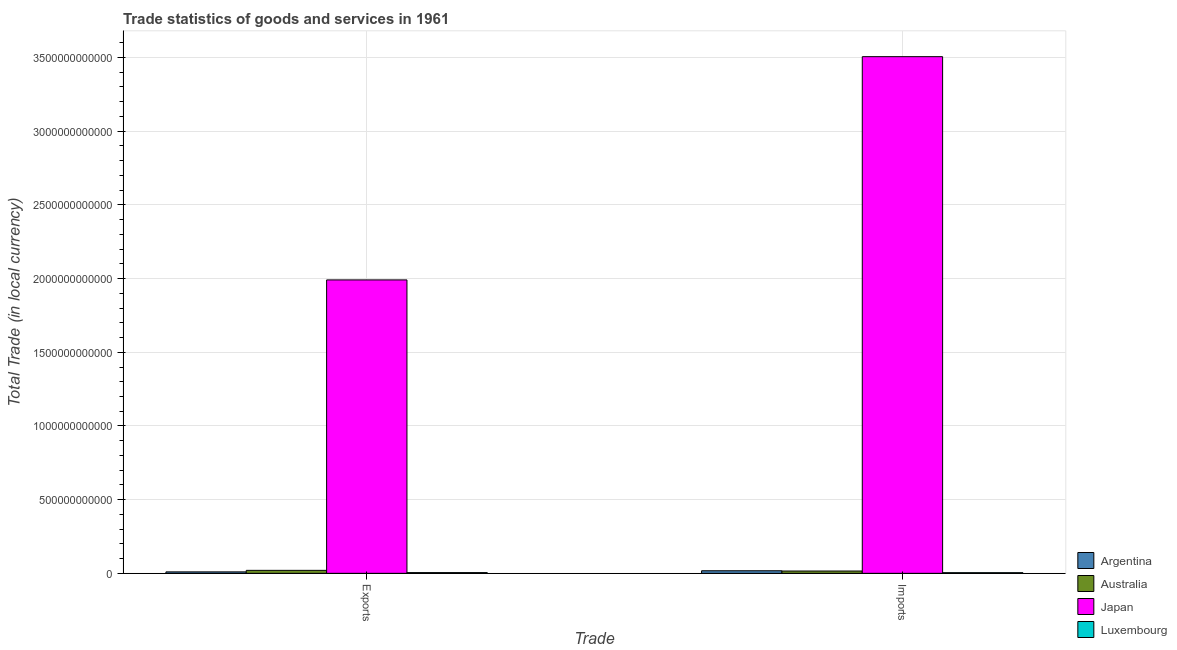How many groups of bars are there?
Ensure brevity in your answer.  2. Are the number of bars per tick equal to the number of legend labels?
Offer a terse response. Yes. How many bars are there on the 2nd tick from the left?
Provide a short and direct response. 4. What is the label of the 2nd group of bars from the left?
Provide a succinct answer. Imports. What is the export of goods and services in Luxembourg?
Give a very brief answer. 4.98e+09. Across all countries, what is the maximum export of goods and services?
Offer a very short reply. 1.99e+12. Across all countries, what is the minimum imports of goods and services?
Make the answer very short. 4.41e+09. In which country was the imports of goods and services minimum?
Make the answer very short. Luxembourg. What is the total export of goods and services in the graph?
Make the answer very short. 2.03e+12. What is the difference between the imports of goods and services in Japan and that in Australia?
Provide a short and direct response. 3.49e+12. What is the difference between the export of goods and services in Japan and the imports of goods and services in Argentina?
Your answer should be very brief. 1.97e+12. What is the average export of goods and services per country?
Ensure brevity in your answer.  5.07e+11. What is the difference between the export of goods and services and imports of goods and services in Australia?
Your answer should be very brief. 4.57e+09. In how many countries, is the export of goods and services greater than 200000000000 LCU?
Your response must be concise. 1. What is the ratio of the export of goods and services in Australia to that in Japan?
Offer a very short reply. 0.01. In how many countries, is the imports of goods and services greater than the average imports of goods and services taken over all countries?
Give a very brief answer. 1. What does the 1st bar from the left in Exports represents?
Offer a terse response. Argentina. What does the 3rd bar from the right in Exports represents?
Ensure brevity in your answer.  Australia. Are all the bars in the graph horizontal?
Offer a terse response. No. How many countries are there in the graph?
Ensure brevity in your answer.  4. What is the difference between two consecutive major ticks on the Y-axis?
Provide a succinct answer. 5.00e+11. Where does the legend appear in the graph?
Give a very brief answer. Bottom right. How are the legend labels stacked?
Offer a terse response. Vertical. What is the title of the graph?
Your answer should be very brief. Trade statistics of goods and services in 1961. What is the label or title of the X-axis?
Your answer should be compact. Trade. What is the label or title of the Y-axis?
Offer a very short reply. Total Trade (in local currency). What is the Total Trade (in local currency) in Argentina in Exports?
Offer a terse response. 9.88e+09. What is the Total Trade (in local currency) in Australia in Exports?
Your answer should be compact. 2.03e+1. What is the Total Trade (in local currency) of Japan in Exports?
Your response must be concise. 1.99e+12. What is the Total Trade (in local currency) of Luxembourg in Exports?
Keep it short and to the point. 4.98e+09. What is the Total Trade (in local currency) in Argentina in Imports?
Provide a succinct answer. 1.74e+1. What is the Total Trade (in local currency) of Australia in Imports?
Keep it short and to the point. 1.57e+1. What is the Total Trade (in local currency) of Japan in Imports?
Offer a terse response. 3.51e+12. What is the Total Trade (in local currency) in Luxembourg in Imports?
Your response must be concise. 4.41e+09. Across all Trade, what is the maximum Total Trade (in local currency) of Argentina?
Give a very brief answer. 1.74e+1. Across all Trade, what is the maximum Total Trade (in local currency) of Australia?
Give a very brief answer. 2.03e+1. Across all Trade, what is the maximum Total Trade (in local currency) of Japan?
Your answer should be compact. 3.51e+12. Across all Trade, what is the maximum Total Trade (in local currency) in Luxembourg?
Give a very brief answer. 4.98e+09. Across all Trade, what is the minimum Total Trade (in local currency) in Argentina?
Offer a very short reply. 9.88e+09. Across all Trade, what is the minimum Total Trade (in local currency) in Australia?
Keep it short and to the point. 1.57e+1. Across all Trade, what is the minimum Total Trade (in local currency) in Japan?
Your answer should be very brief. 1.99e+12. Across all Trade, what is the minimum Total Trade (in local currency) in Luxembourg?
Provide a succinct answer. 4.41e+09. What is the total Total Trade (in local currency) in Argentina in the graph?
Provide a short and direct response. 2.73e+1. What is the total Total Trade (in local currency) of Australia in the graph?
Make the answer very short. 3.60e+1. What is the total Total Trade (in local currency) in Japan in the graph?
Keep it short and to the point. 5.50e+12. What is the total Total Trade (in local currency) of Luxembourg in the graph?
Offer a terse response. 9.39e+09. What is the difference between the Total Trade (in local currency) in Argentina in Exports and that in Imports?
Offer a very short reply. -7.56e+09. What is the difference between the Total Trade (in local currency) of Australia in Exports and that in Imports?
Your answer should be very brief. 4.57e+09. What is the difference between the Total Trade (in local currency) in Japan in Exports and that in Imports?
Give a very brief answer. -1.51e+12. What is the difference between the Total Trade (in local currency) of Luxembourg in Exports and that in Imports?
Give a very brief answer. 5.66e+08. What is the difference between the Total Trade (in local currency) in Argentina in Exports and the Total Trade (in local currency) in Australia in Imports?
Ensure brevity in your answer.  -5.81e+09. What is the difference between the Total Trade (in local currency) in Argentina in Exports and the Total Trade (in local currency) in Japan in Imports?
Your answer should be compact. -3.50e+12. What is the difference between the Total Trade (in local currency) of Argentina in Exports and the Total Trade (in local currency) of Luxembourg in Imports?
Keep it short and to the point. 5.47e+09. What is the difference between the Total Trade (in local currency) of Australia in Exports and the Total Trade (in local currency) of Japan in Imports?
Your response must be concise. -3.49e+12. What is the difference between the Total Trade (in local currency) of Australia in Exports and the Total Trade (in local currency) of Luxembourg in Imports?
Keep it short and to the point. 1.59e+1. What is the difference between the Total Trade (in local currency) of Japan in Exports and the Total Trade (in local currency) of Luxembourg in Imports?
Your answer should be very brief. 1.99e+12. What is the average Total Trade (in local currency) of Argentina per Trade?
Provide a succinct answer. 1.37e+1. What is the average Total Trade (in local currency) in Australia per Trade?
Provide a succinct answer. 1.80e+1. What is the average Total Trade (in local currency) of Japan per Trade?
Provide a short and direct response. 2.75e+12. What is the average Total Trade (in local currency) of Luxembourg per Trade?
Your answer should be compact. 4.69e+09. What is the difference between the Total Trade (in local currency) in Argentina and Total Trade (in local currency) in Australia in Exports?
Offer a terse response. -1.04e+1. What is the difference between the Total Trade (in local currency) of Argentina and Total Trade (in local currency) of Japan in Exports?
Ensure brevity in your answer.  -1.98e+12. What is the difference between the Total Trade (in local currency) in Argentina and Total Trade (in local currency) in Luxembourg in Exports?
Make the answer very short. 4.91e+09. What is the difference between the Total Trade (in local currency) in Australia and Total Trade (in local currency) in Japan in Exports?
Provide a short and direct response. -1.97e+12. What is the difference between the Total Trade (in local currency) in Australia and Total Trade (in local currency) in Luxembourg in Exports?
Give a very brief answer. 1.53e+1. What is the difference between the Total Trade (in local currency) in Japan and Total Trade (in local currency) in Luxembourg in Exports?
Offer a terse response. 1.99e+12. What is the difference between the Total Trade (in local currency) of Argentina and Total Trade (in local currency) of Australia in Imports?
Ensure brevity in your answer.  1.74e+09. What is the difference between the Total Trade (in local currency) of Argentina and Total Trade (in local currency) of Japan in Imports?
Your answer should be compact. -3.49e+12. What is the difference between the Total Trade (in local currency) of Argentina and Total Trade (in local currency) of Luxembourg in Imports?
Make the answer very short. 1.30e+1. What is the difference between the Total Trade (in local currency) of Australia and Total Trade (in local currency) of Japan in Imports?
Make the answer very short. -3.49e+12. What is the difference between the Total Trade (in local currency) of Australia and Total Trade (in local currency) of Luxembourg in Imports?
Ensure brevity in your answer.  1.13e+1. What is the difference between the Total Trade (in local currency) in Japan and Total Trade (in local currency) in Luxembourg in Imports?
Offer a terse response. 3.50e+12. What is the ratio of the Total Trade (in local currency) of Argentina in Exports to that in Imports?
Provide a succinct answer. 0.57. What is the ratio of the Total Trade (in local currency) of Australia in Exports to that in Imports?
Provide a succinct answer. 1.29. What is the ratio of the Total Trade (in local currency) in Japan in Exports to that in Imports?
Offer a terse response. 0.57. What is the ratio of the Total Trade (in local currency) of Luxembourg in Exports to that in Imports?
Provide a short and direct response. 1.13. What is the difference between the highest and the second highest Total Trade (in local currency) in Argentina?
Offer a terse response. 7.56e+09. What is the difference between the highest and the second highest Total Trade (in local currency) of Australia?
Make the answer very short. 4.57e+09. What is the difference between the highest and the second highest Total Trade (in local currency) of Japan?
Offer a terse response. 1.51e+12. What is the difference between the highest and the second highest Total Trade (in local currency) of Luxembourg?
Your answer should be very brief. 5.66e+08. What is the difference between the highest and the lowest Total Trade (in local currency) in Argentina?
Offer a terse response. 7.56e+09. What is the difference between the highest and the lowest Total Trade (in local currency) of Australia?
Ensure brevity in your answer.  4.57e+09. What is the difference between the highest and the lowest Total Trade (in local currency) of Japan?
Offer a very short reply. 1.51e+12. What is the difference between the highest and the lowest Total Trade (in local currency) of Luxembourg?
Make the answer very short. 5.66e+08. 